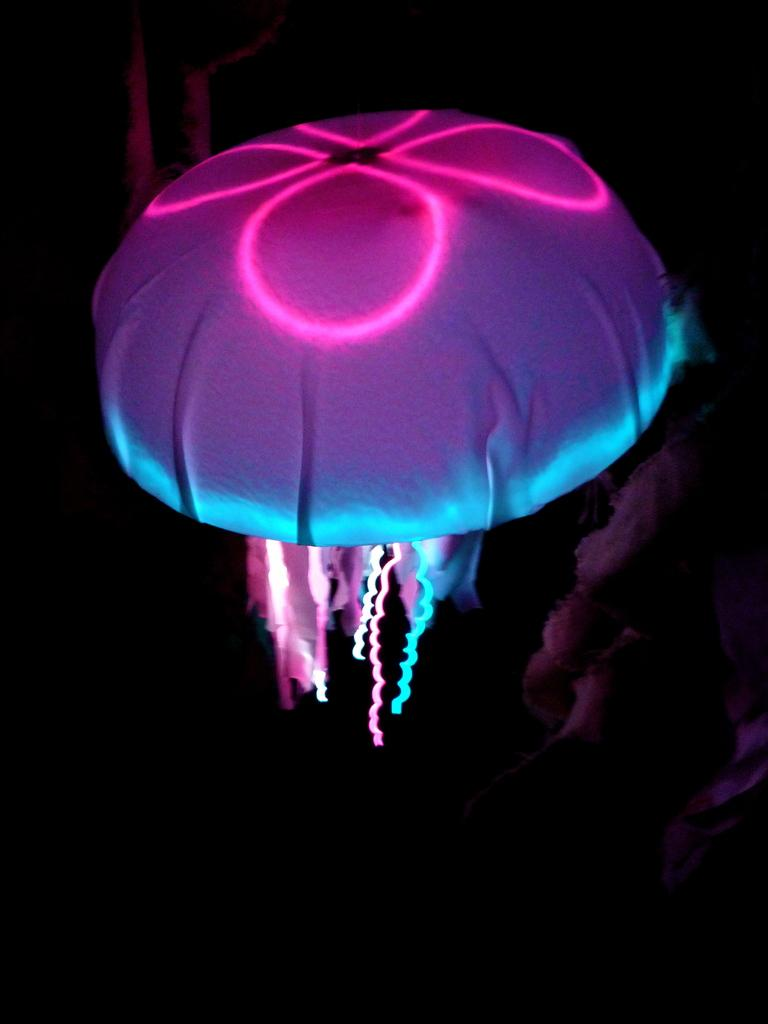What type of sea creature is in the image? There is a jellyfish in the image. Can you describe the lighting in the image? There is light visible in the image. Where is the parcel located in the image? There is no parcel present in the image. What type of club can be seen in the image? There is no club present in the image. 